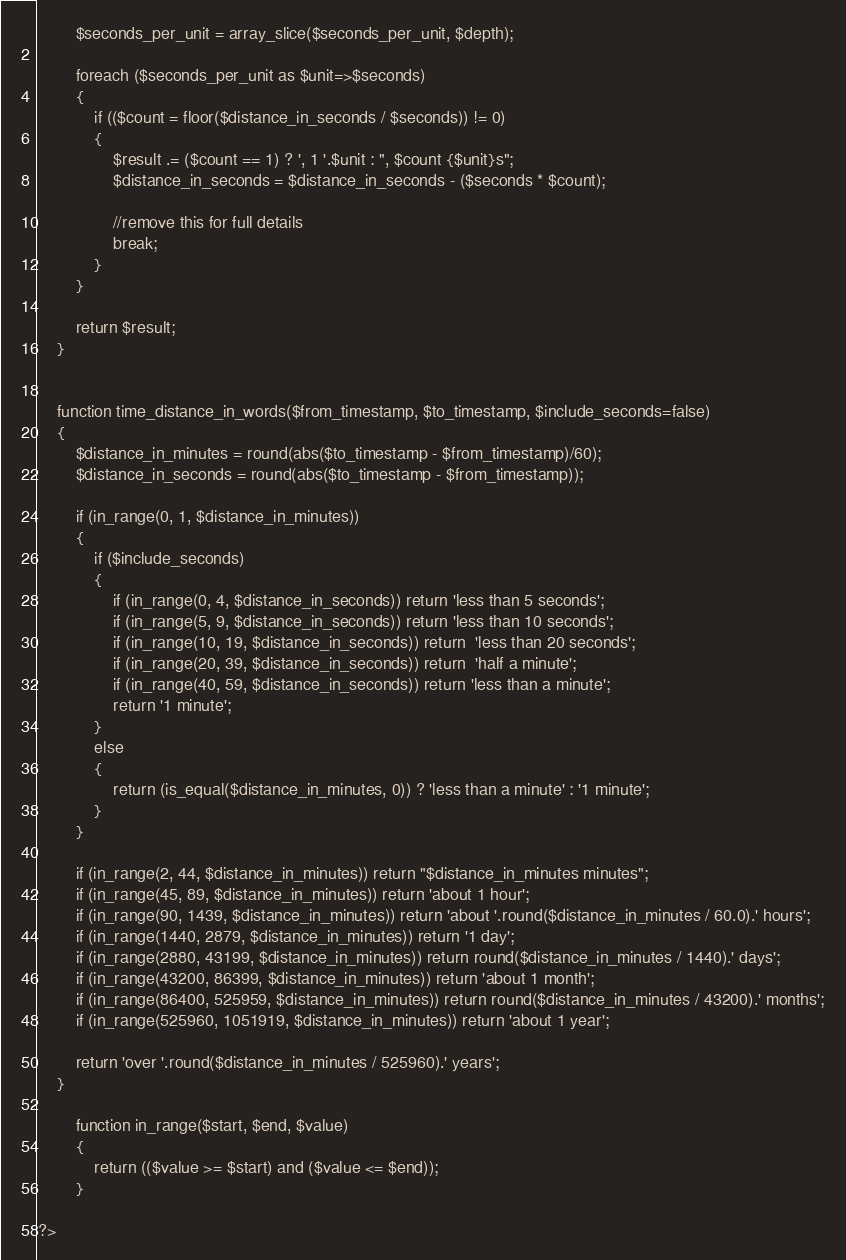Convert code to text. <code><loc_0><loc_0><loc_500><loc_500><_PHP_>		$seconds_per_unit = array_slice($seconds_per_unit, $depth);

		foreach ($seconds_per_unit as $unit=>$seconds)
		{
			if (($count = floor($distance_in_seconds / $seconds)) != 0)
			{
				$result .= ($count == 1) ? ', 1 '.$unit : ", $count {$unit}s";
				$distance_in_seconds = $distance_in_seconds - ($seconds * $count);

				//remove this for full details
				break;
			}
		}

		return $result;
	}


	function time_distance_in_words($from_timestamp, $to_timestamp, $include_seconds=false)
	{
        $distance_in_minutes = round(abs($to_timestamp - $from_timestamp)/60);
        $distance_in_seconds = round(abs($to_timestamp - $from_timestamp));

		if (in_range(0, 1, $distance_in_minutes))
		{
			if ($include_seconds)
			{
				if (in_range(0, 4, $distance_in_seconds)) return 'less than 5 seconds';
				if (in_range(5, 9, $distance_in_seconds)) return 'less than 10 seconds';
				if (in_range(10, 19, $distance_in_seconds)) return  'less than 20 seconds';
				if (in_range(20, 39, $distance_in_seconds)) return  'half a minute';
				if (in_range(40, 59, $distance_in_seconds)) return 'less than a minute';
				return '1 minute';
			}
			else
			{
				return (is_equal($distance_in_minutes, 0)) ? 'less than a minute' : '1 minute';
			}
		}

		if (in_range(2, 44, $distance_in_minutes)) return "$distance_in_minutes minutes";
		if (in_range(45, 89, $distance_in_minutes)) return 'about 1 hour';
		if (in_range(90, 1439, $distance_in_minutes)) return 'about '.round($distance_in_minutes / 60.0).' hours';
		if (in_range(1440, 2879, $distance_in_minutes)) return '1 day';
		if (in_range(2880, 43199, $distance_in_minutes)) return round($distance_in_minutes / 1440).' days';
		if (in_range(43200, 86399, $distance_in_minutes)) return 'about 1 month';
		if (in_range(86400, 525959, $distance_in_minutes)) return round($distance_in_minutes / 43200).' months';
		if (in_range(525960, 1051919, $distance_in_minutes)) return 'about 1 year';

		return 'over '.round($distance_in_minutes / 525960).' years';
	}

		function in_range($start, $end, $value)
		{
			return (($value >= $start) and ($value <= $end));
		}

?></code> 